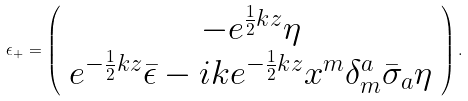<formula> <loc_0><loc_0><loc_500><loc_500>\epsilon _ { + } = \left ( \begin{array} { c } - e ^ { \frac { 1 } { 2 } k z } \eta \\ e ^ { - \frac { 1 } { 2 } k z } \bar { \epsilon } - i k e ^ { - \frac { 1 } { 2 } k z } x ^ { m } \delta _ { m } ^ { a } \bar { \sigma } _ { a } \eta \end{array} \right ) .</formula> 